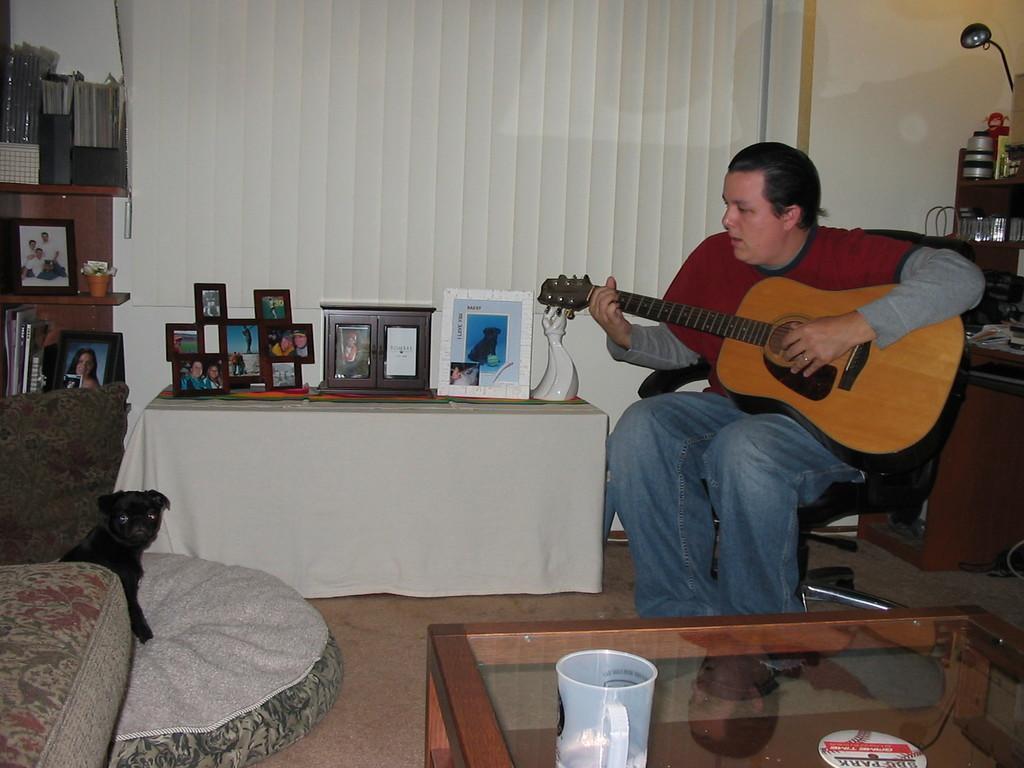Could you give a brief overview of what you see in this image? Here we can see one man sitting on a chair and playing a guitar. Near to him there is a table and photo frames on it. This is a desk and we can see photo frames over here and a cup. This is a floor. Here we can see sofa and a animal sitting on a bed. Here on the table we can see a mug in white colour. 